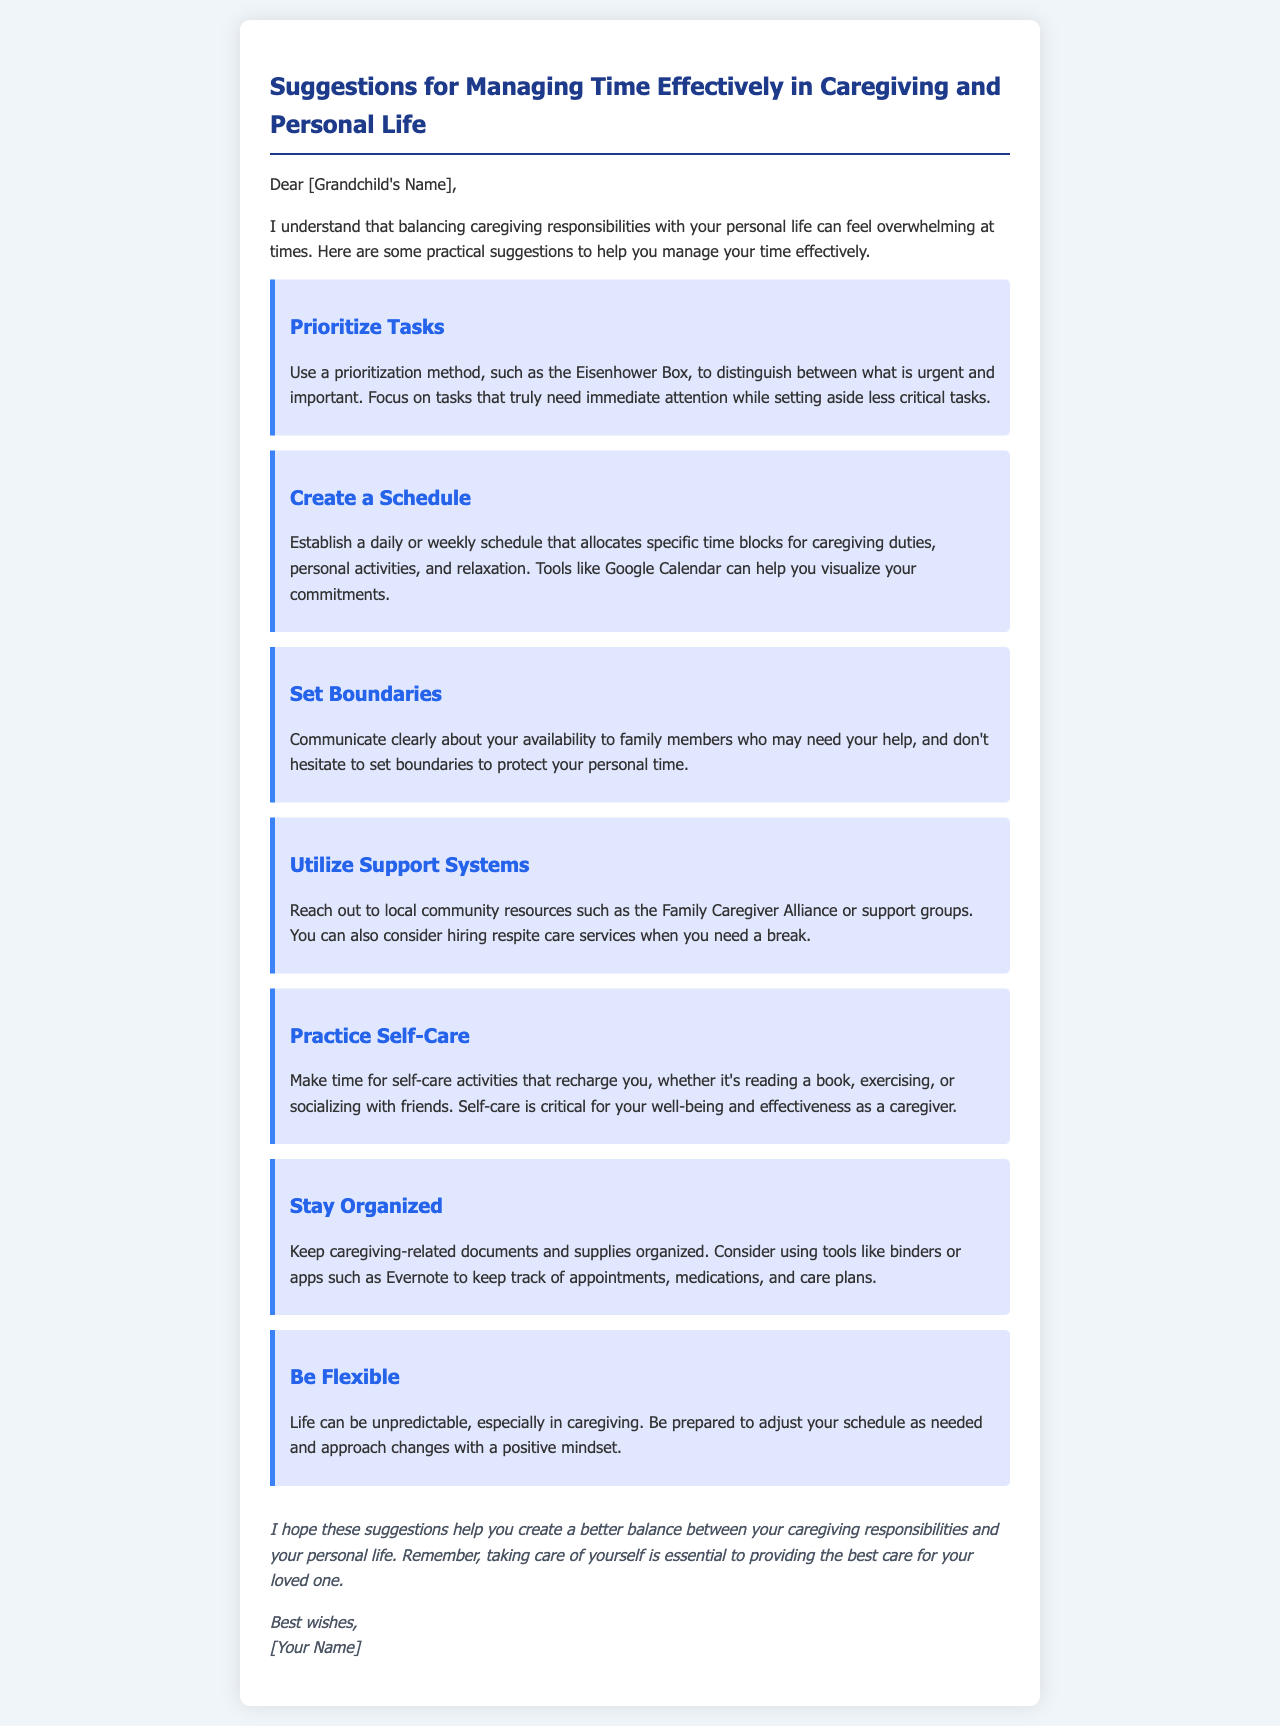What is the title of the document? The title is displayed prominently at the top of the document, clearly stating the main subject of the letter.
Answer: Suggestions for Managing Time Effectively in Caregiving and Personal Life How many suggestions are provided? The document contains a list of suggestions, which can be counted by reviewing each section titled as “suggestion.”
Answer: Seven What is the first suggestion? The first suggestion is listed at the beginning of the series of tips and outlines the importance of prioritization.
Answer: Prioritize Tasks What is the overall theme of the letter? The letter aims to address a specific concern faced by the recipient, guiding them on how to manage their responsibilities effectively.
Answer: Time management in caregiving Which community resource is mentioned? The letter suggests reaching out to specific local organizations that can offer support to caregivers.
Answer: Family Caregiver Alliance What practice is emphasized for personal well-being? The document highlights the importance of maintaining personal health and well-being as a caregiver through specific activities.
Answer: Self-care What is advised regarding communication with family members? One of the key suggestions in the document recommends clearly stating one's availability and protecting personal time.
Answer: Set boundaries How should a caregiver handle unpredictability? The document notes that caregivers may face unexpected situations and need to be adaptable in their approach.
Answer: Be flexible 